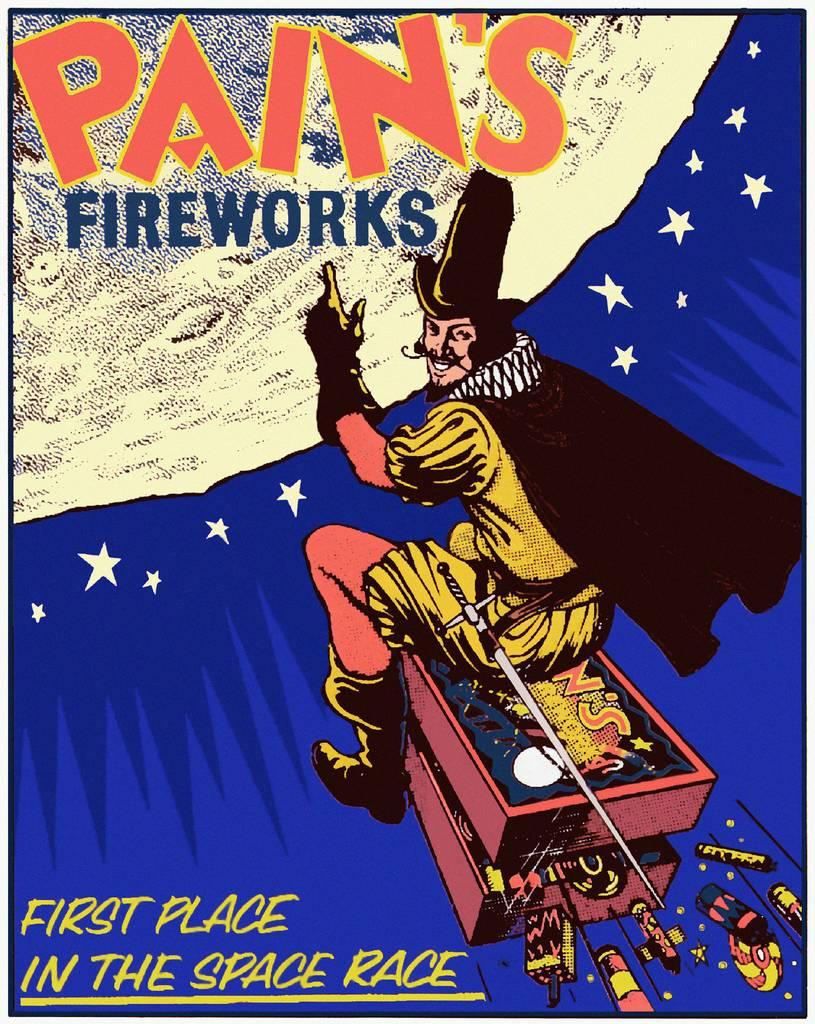<image>
Render a clear and concise summary of the photo. An advertisement for Pain's Fireworks depicting a man being shot to the moon. 